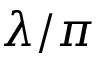Convert formula to latex. <formula><loc_0><loc_0><loc_500><loc_500>\lambda / \pi</formula> 